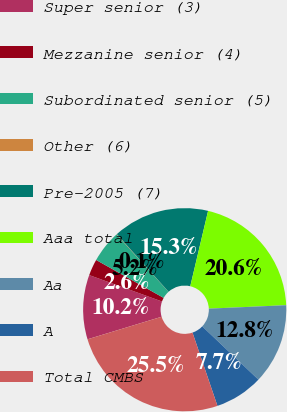Convert chart to OTSL. <chart><loc_0><loc_0><loc_500><loc_500><pie_chart><fcel>Super senior (3)<fcel>Mezzanine senior (4)<fcel>Subordinated senior (5)<fcel>Other (6)<fcel>Pre-2005 (7)<fcel>Aaa total<fcel>Aa<fcel>A<fcel>Total CMBS<nl><fcel>10.24%<fcel>2.61%<fcel>5.15%<fcel>0.06%<fcel>15.34%<fcel>20.59%<fcel>12.79%<fcel>7.7%<fcel>25.52%<nl></chart> 